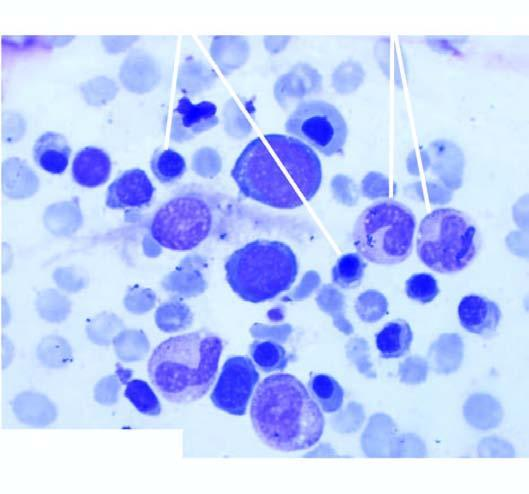what aspirate shows micronormoblastic erythropoiesis?
Answer the question using a single word or phrase. Examination of bone marrow 